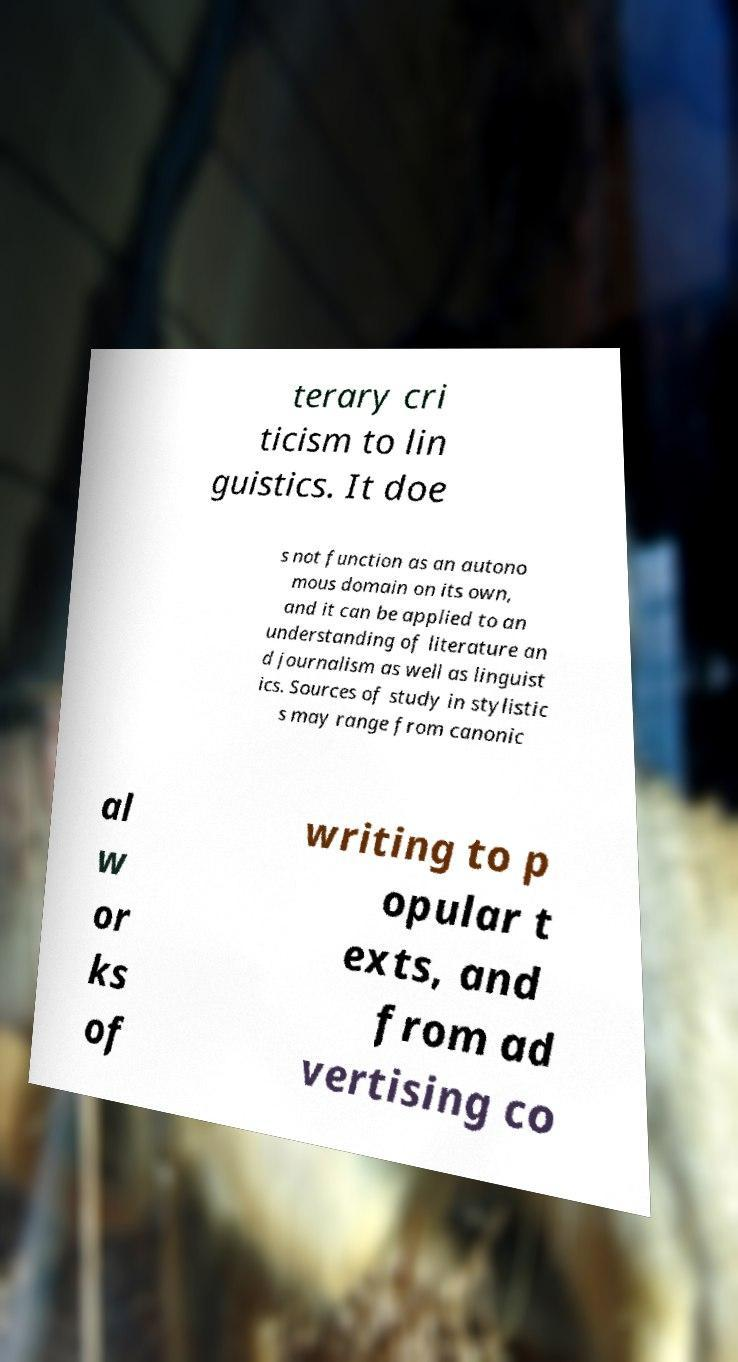Can you read and provide the text displayed in the image?This photo seems to have some interesting text. Can you extract and type it out for me? terary cri ticism to lin guistics. It doe s not function as an autono mous domain on its own, and it can be applied to an understanding of literature an d journalism as well as linguist ics. Sources of study in stylistic s may range from canonic al w or ks of writing to p opular t exts, and from ad vertising co 